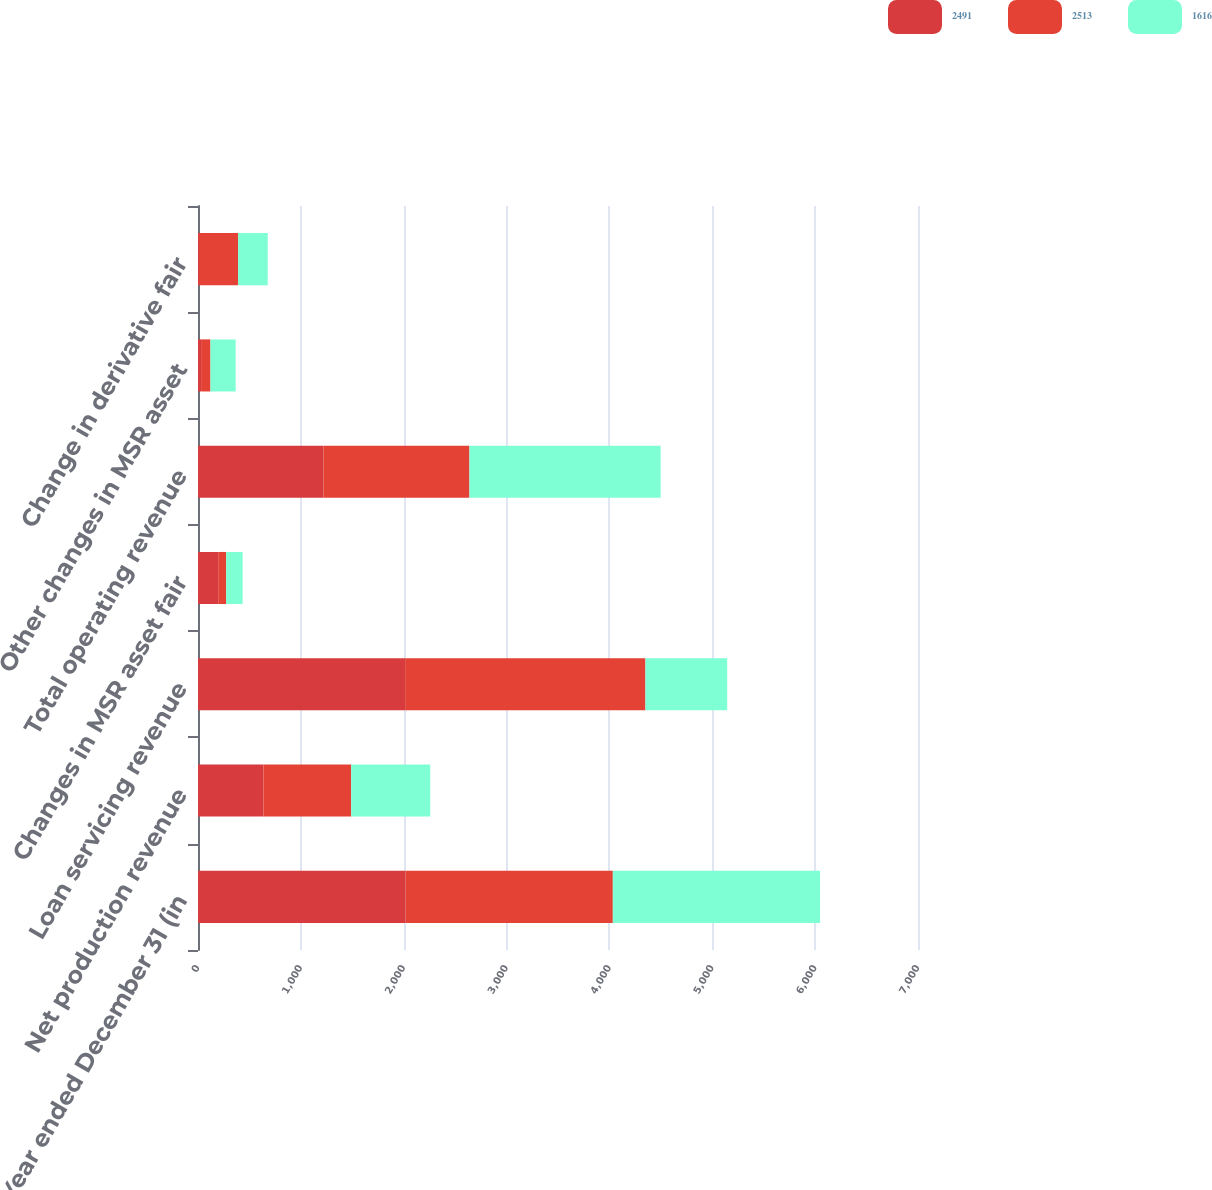Convert chart. <chart><loc_0><loc_0><loc_500><loc_500><stacked_bar_chart><ecel><fcel>Year ended December 31 (in<fcel>Net production revenue<fcel>Loan servicing revenue<fcel>Changes in MSR asset fair<fcel>Total operating revenue<fcel>Other changes in MSR asset<fcel>Change in derivative fair<nl><fcel>2491<fcel>2017<fcel>636<fcel>2014<fcel>202<fcel>1219<fcel>30<fcel>10<nl><fcel>2513<fcel>2016<fcel>853<fcel>2336<fcel>72<fcel>1420<fcel>91<fcel>380<nl><fcel>1616<fcel>2015<fcel>769<fcel>795<fcel>160<fcel>1859<fcel>245<fcel>288<nl></chart> 